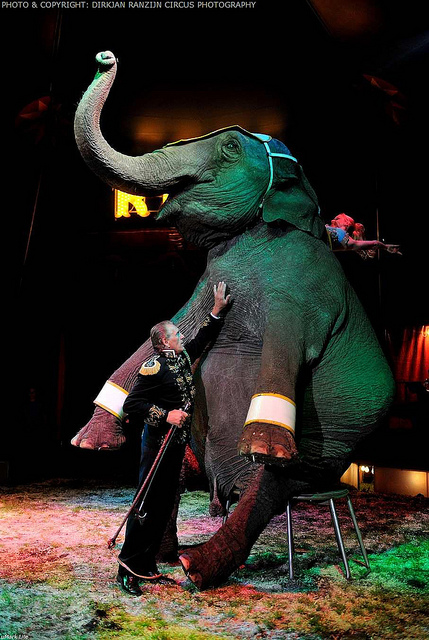Read and extract the text from this image. RANZUN PHOTO DIRKJAN CIRCUS PHOTOGRAPHY COPYRIGHT 